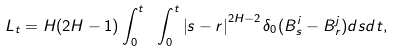Convert formula to latex. <formula><loc_0><loc_0><loc_500><loc_500>L _ { t } = H ( 2 H - 1 ) \int _ { 0 } ^ { t } \ \int _ { 0 } ^ { t } \left | s - r \right | ^ { 2 H - 2 } \delta _ { 0 } ( B _ { s } ^ { i } - B _ { r } ^ { j } ) d s d t ,</formula> 